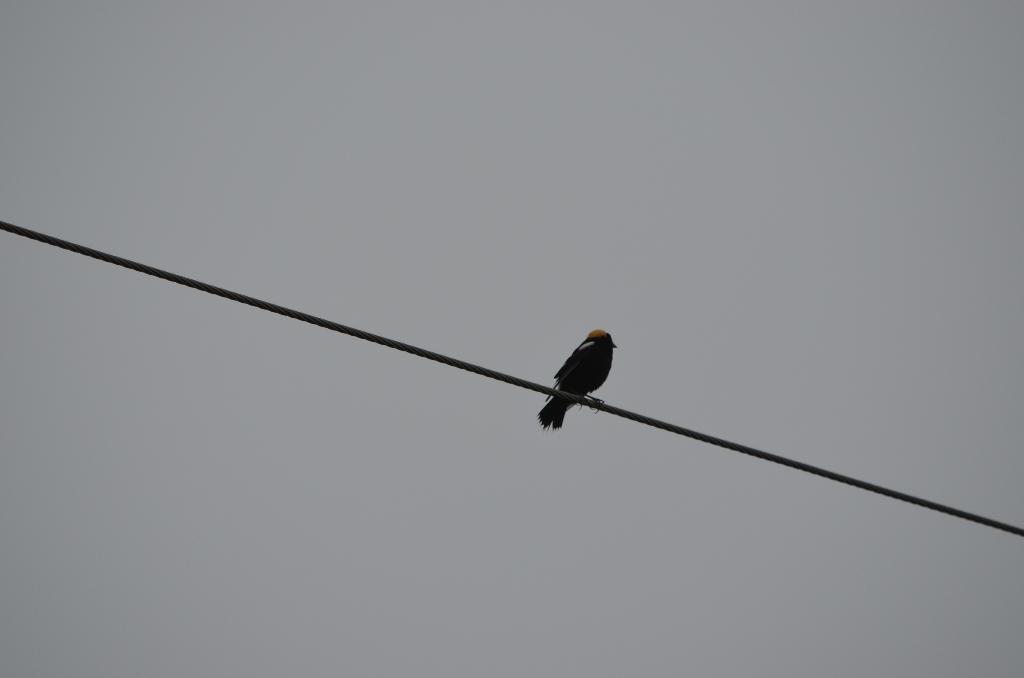Could you give a brief overview of what you see in this image? In this image I can see a bird on the wire. In the background, I can see the sky. 